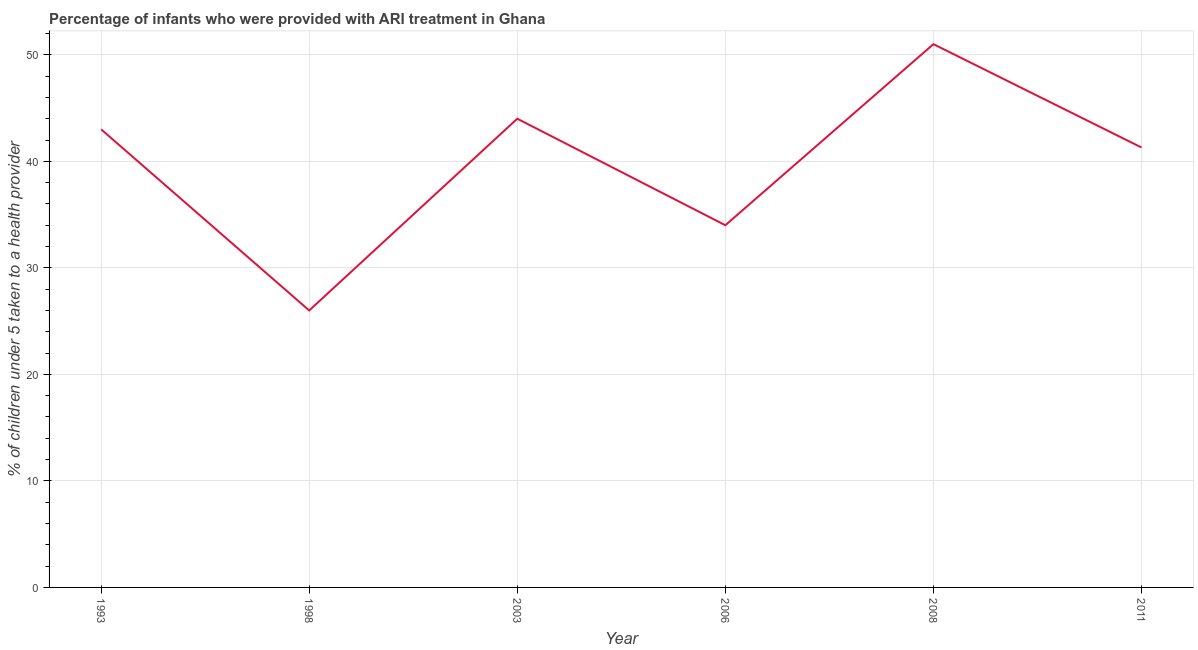What is the percentage of children who were provided with ari treatment in 2011?
Offer a very short reply. 41.3. Across all years, what is the maximum percentage of children who were provided with ari treatment?
Provide a short and direct response. 51. Across all years, what is the minimum percentage of children who were provided with ari treatment?
Make the answer very short. 26. In which year was the percentage of children who were provided with ari treatment maximum?
Your answer should be compact. 2008. In which year was the percentage of children who were provided with ari treatment minimum?
Offer a terse response. 1998. What is the sum of the percentage of children who were provided with ari treatment?
Give a very brief answer. 239.3. What is the average percentage of children who were provided with ari treatment per year?
Your answer should be very brief. 39.88. What is the median percentage of children who were provided with ari treatment?
Ensure brevity in your answer.  42.15. Do a majority of the years between 2003 and 2008 (inclusive) have percentage of children who were provided with ari treatment greater than 44 %?
Provide a succinct answer. No. What is the ratio of the percentage of children who were provided with ari treatment in 2003 to that in 2006?
Offer a terse response. 1.29. In how many years, is the percentage of children who were provided with ari treatment greater than the average percentage of children who were provided with ari treatment taken over all years?
Offer a terse response. 4. Does the percentage of children who were provided with ari treatment monotonically increase over the years?
Your response must be concise. No. How many lines are there?
Provide a short and direct response. 1. How many years are there in the graph?
Offer a very short reply. 6. What is the difference between two consecutive major ticks on the Y-axis?
Offer a very short reply. 10. Are the values on the major ticks of Y-axis written in scientific E-notation?
Keep it short and to the point. No. Does the graph contain any zero values?
Ensure brevity in your answer.  No. What is the title of the graph?
Your answer should be compact. Percentage of infants who were provided with ARI treatment in Ghana. What is the label or title of the X-axis?
Your answer should be compact. Year. What is the label or title of the Y-axis?
Offer a very short reply. % of children under 5 taken to a health provider. What is the % of children under 5 taken to a health provider of 2011?
Offer a terse response. 41.3. What is the difference between the % of children under 5 taken to a health provider in 1993 and 1998?
Offer a very short reply. 17. What is the difference between the % of children under 5 taken to a health provider in 1993 and 2003?
Offer a terse response. -1. What is the difference between the % of children under 5 taken to a health provider in 1993 and 2008?
Give a very brief answer. -8. What is the difference between the % of children under 5 taken to a health provider in 1998 and 2003?
Provide a short and direct response. -18. What is the difference between the % of children under 5 taken to a health provider in 1998 and 2006?
Provide a short and direct response. -8. What is the difference between the % of children under 5 taken to a health provider in 1998 and 2008?
Your answer should be compact. -25. What is the difference between the % of children under 5 taken to a health provider in 1998 and 2011?
Ensure brevity in your answer.  -15.3. What is the difference between the % of children under 5 taken to a health provider in 2003 and 2011?
Offer a very short reply. 2.7. What is the difference between the % of children under 5 taken to a health provider in 2006 and 2011?
Your response must be concise. -7.3. What is the ratio of the % of children under 5 taken to a health provider in 1993 to that in 1998?
Provide a succinct answer. 1.65. What is the ratio of the % of children under 5 taken to a health provider in 1993 to that in 2006?
Your answer should be compact. 1.26. What is the ratio of the % of children under 5 taken to a health provider in 1993 to that in 2008?
Your response must be concise. 0.84. What is the ratio of the % of children under 5 taken to a health provider in 1993 to that in 2011?
Provide a succinct answer. 1.04. What is the ratio of the % of children under 5 taken to a health provider in 1998 to that in 2003?
Give a very brief answer. 0.59. What is the ratio of the % of children under 5 taken to a health provider in 1998 to that in 2006?
Provide a short and direct response. 0.77. What is the ratio of the % of children under 5 taken to a health provider in 1998 to that in 2008?
Make the answer very short. 0.51. What is the ratio of the % of children under 5 taken to a health provider in 1998 to that in 2011?
Provide a succinct answer. 0.63. What is the ratio of the % of children under 5 taken to a health provider in 2003 to that in 2006?
Ensure brevity in your answer.  1.29. What is the ratio of the % of children under 5 taken to a health provider in 2003 to that in 2008?
Offer a very short reply. 0.86. What is the ratio of the % of children under 5 taken to a health provider in 2003 to that in 2011?
Keep it short and to the point. 1.06. What is the ratio of the % of children under 5 taken to a health provider in 2006 to that in 2008?
Keep it short and to the point. 0.67. What is the ratio of the % of children under 5 taken to a health provider in 2006 to that in 2011?
Offer a very short reply. 0.82. What is the ratio of the % of children under 5 taken to a health provider in 2008 to that in 2011?
Your answer should be compact. 1.24. 